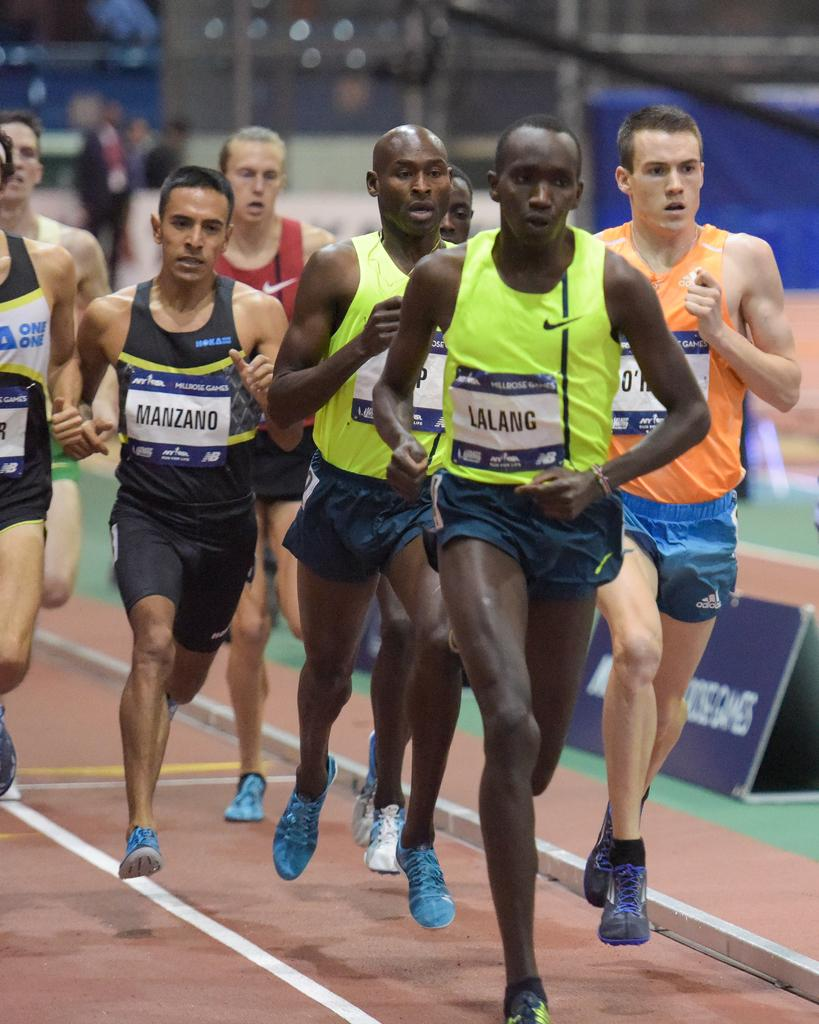<image>
Write a terse but informative summary of the picture. Lalang is the name of the runner in first place. 